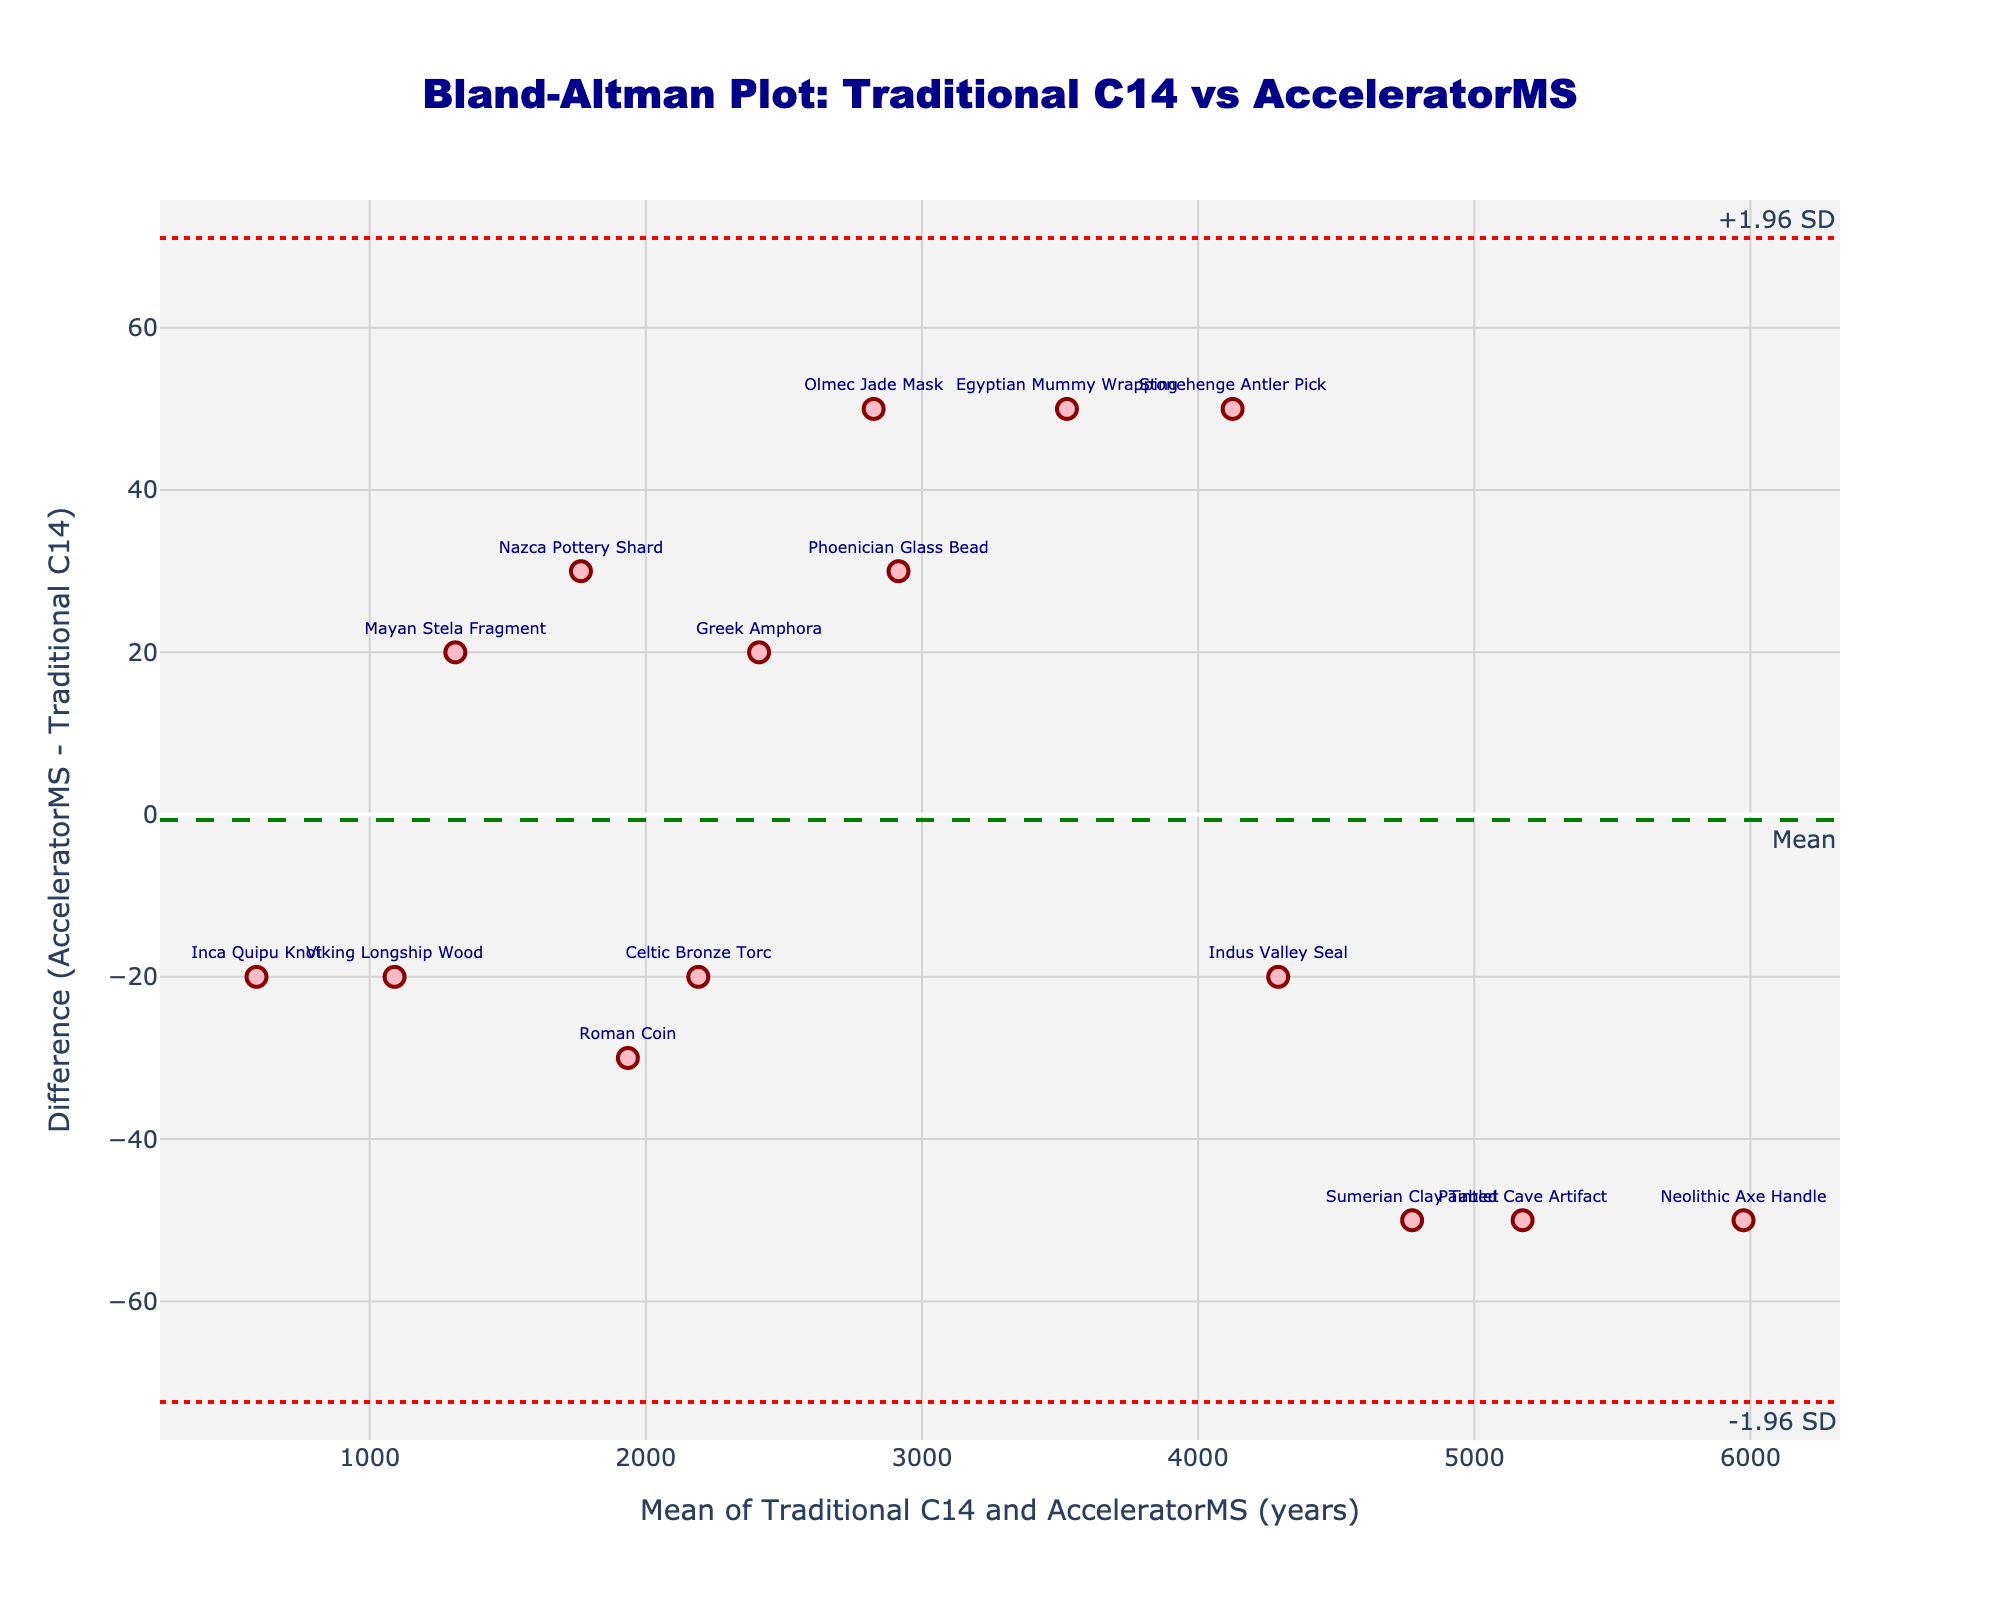How many artifacts are plotted on the graph? Count the number of data points or markers on the graph to determine the total number of artifacts represented.
Answer: 15 What is the mean difference between the traditional C14 and AcceleratorMS techniques? The mean difference is indicated by the dashed green line labeled "Mean" on the y-axis.
Answer: 0 Which artifact has the largest negative difference between the two dating methods? Locate the data point with the highest negative value on the y-axis of the Bland-Altman plot. From the text labels, identify the corresponding artifact.
Answer: Painted Cave Artifact What are the ±1.96 standard deviation limits for the differences? Identify the positions of the dotted red lines labeled "+1.96 SD" and "-1.96 SD" on the y-axis to read the values.
Answer: ±50 How many artifacts fall outside the ±1.96 standard deviation limits? Count the number of data points that fall outside the range of the two dotted red lines.
Answer: 0 For which artifact is the average date almost exactly 4100 years? Find the data point closest to the 4100 value on the x-axis (mean) and read the corresponding artifact label.
Answer: Stonehenge Antler Pick Which artifact has a difference of exactly 50 years between the two dating methods? Identify the data points that lie exactly on the y-axis value of 50 and read the corresponding artifact labels.
Answer: Olmec Jade Mask, Egyptian Mummy Wrapping, Stonehenge Antler Pick Is there any visible bias towards one of the dating methods from the plot? Look for any systematic trend or consistent offset of data points from the horizontal dashed green line labeled "Mean." An equal distribution around this line indicates no visible bias.
Answer: No What is the overall trend in the difference as the mean date increases? Observe if there is any clear upward or downward pattern formed by the data points as you move from left to right along the x-axis.
Answer: No clear trend Which artifact has the smallest mean date, and what is its corresponding difference? Identify the data point farthest to the left on the x-axis, note the artifact label, and read the corresponding y-axis value for the difference.
Answer: Inca Quipu Knot, -20 